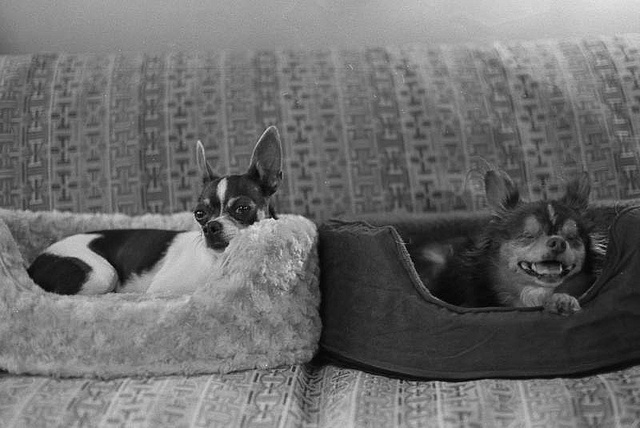Describe the objects in this image and their specific colors. I can see couch in gray, darkgray, black, and lightgray tones, dog in black and gray tones, and dog in gray, black, darkgray, and lightgray tones in this image. 